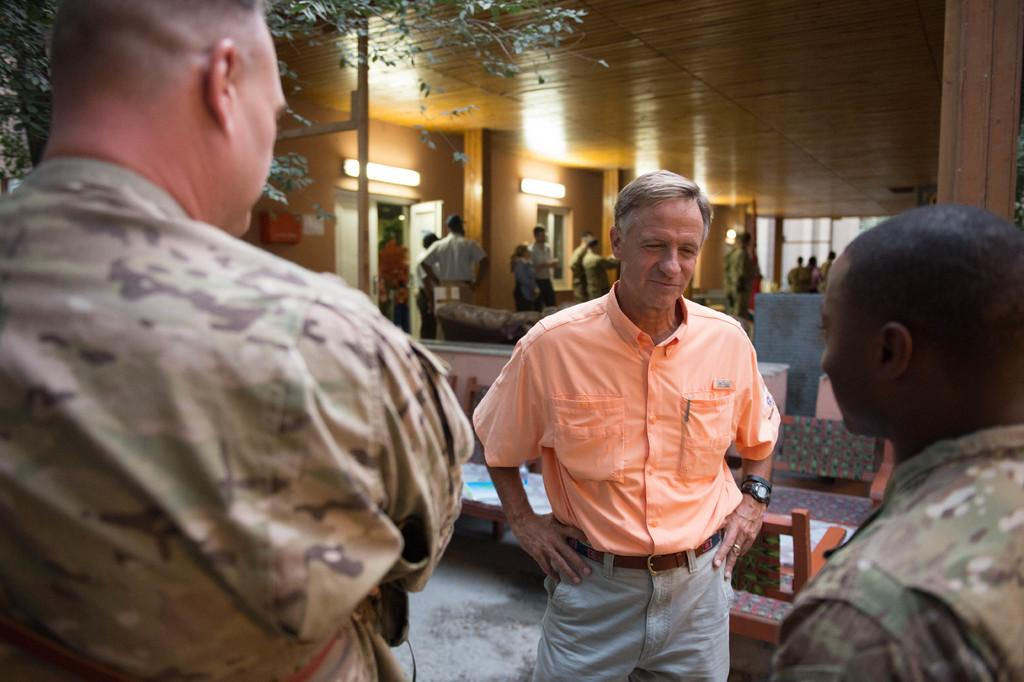What can be seen in the image involving people? There are people standing in the image. What type of furniture is present in the image? There are chairs in the image. What natural element is visible in the image? There is a tree in the image. What type of illumination is present in the image? There are lights in the image. Can you describe the clothing of one of the people in the image? A man is wearing an orange shirt in the image. What accessory is the man wearing in the image? The man is wearing a black wristwatch in the image. What type of trouble is the rose causing in the image? There is no rose present in the image, so it cannot cause any trouble. Can you provide an example of the man's actions in the image? The provided facts do not describe the man's actions, so it is impossible to provide an example. 